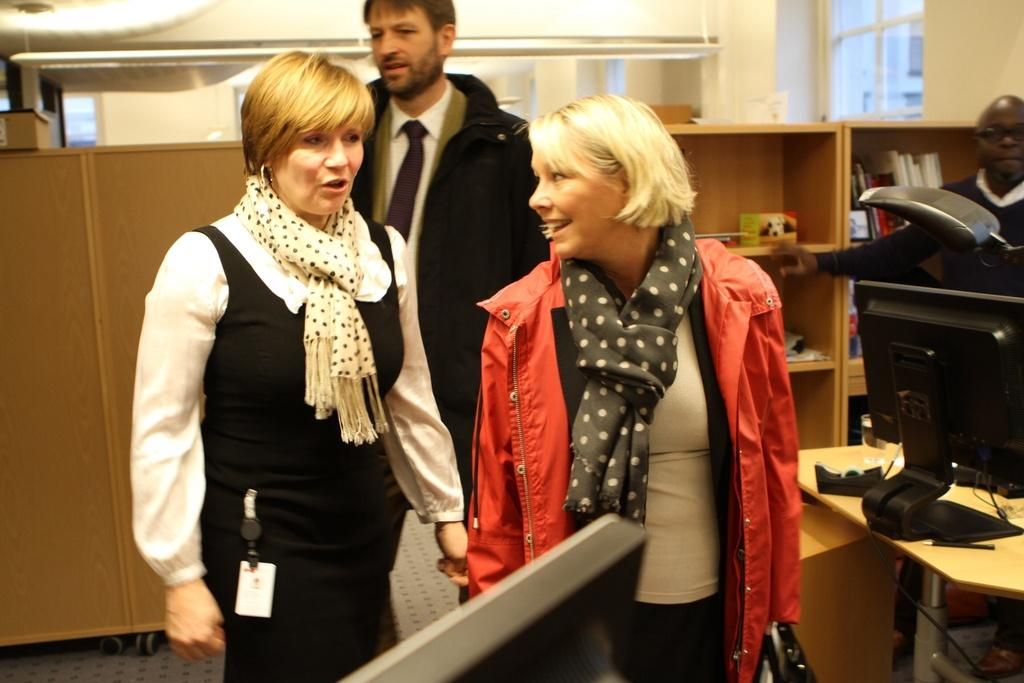What is happening in the image? There are people standing in the image. What can be seen on the table in the image? There is a black color monitor on a table. What is visible in the background of the image? There are two racks in the background of the image. Is there a beggar asking for money in the image? There is no beggar present in the image. Can you see any steam coming from the monitor in the image? There is no steam visible in the image. 